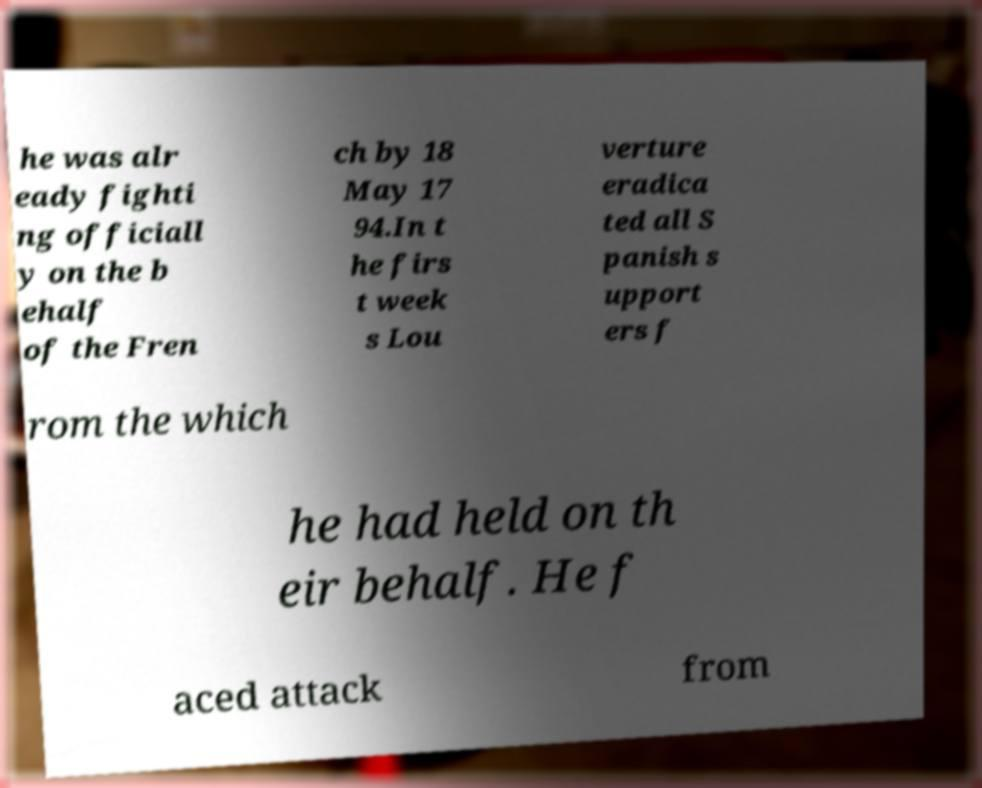Can you accurately transcribe the text from the provided image for me? he was alr eady fighti ng officiall y on the b ehalf of the Fren ch by 18 May 17 94.In t he firs t week s Lou verture eradica ted all S panish s upport ers f rom the which he had held on th eir behalf. He f aced attack from 